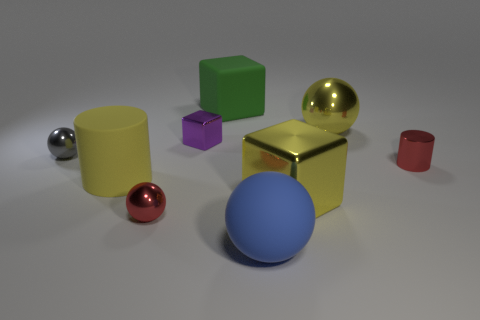Add 1 tiny blue matte objects. How many objects exist? 10 Subtract all big blue matte spheres. How many spheres are left? 3 Subtract 2 spheres. How many spheres are left? 2 Subtract all gray balls. How many balls are left? 3 Subtract all cubes. How many objects are left? 6 Add 2 big green matte objects. How many big green matte objects exist? 3 Subtract 1 green blocks. How many objects are left? 8 Subtract all yellow cubes. Subtract all yellow balls. How many cubes are left? 2 Subtract all metal things. Subtract all big purple spheres. How many objects are left? 3 Add 6 tiny cylinders. How many tiny cylinders are left? 7 